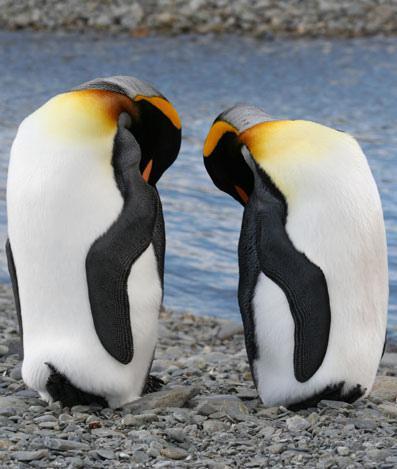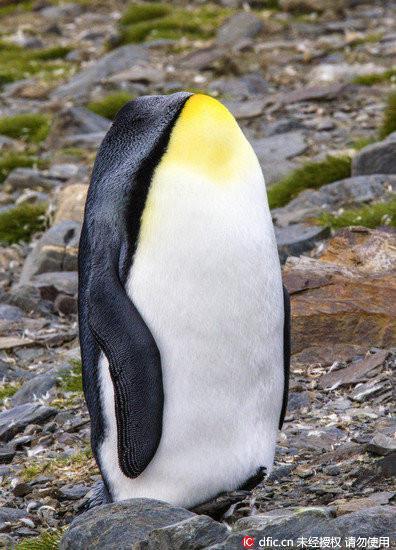The first image is the image on the left, the second image is the image on the right. Given the left and right images, does the statement "At least one of the images includes a penguin that is lying down." hold true? Answer yes or no. No. The first image is the image on the left, the second image is the image on the right. Examine the images to the left and right. Is the description "One image has a penguin surrounded by grass and rocks." accurate? Answer yes or no. Yes. 